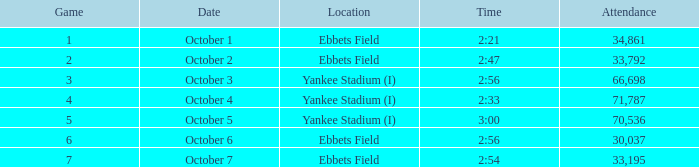The game of 6 has what minimum attendance? 30037.0. 